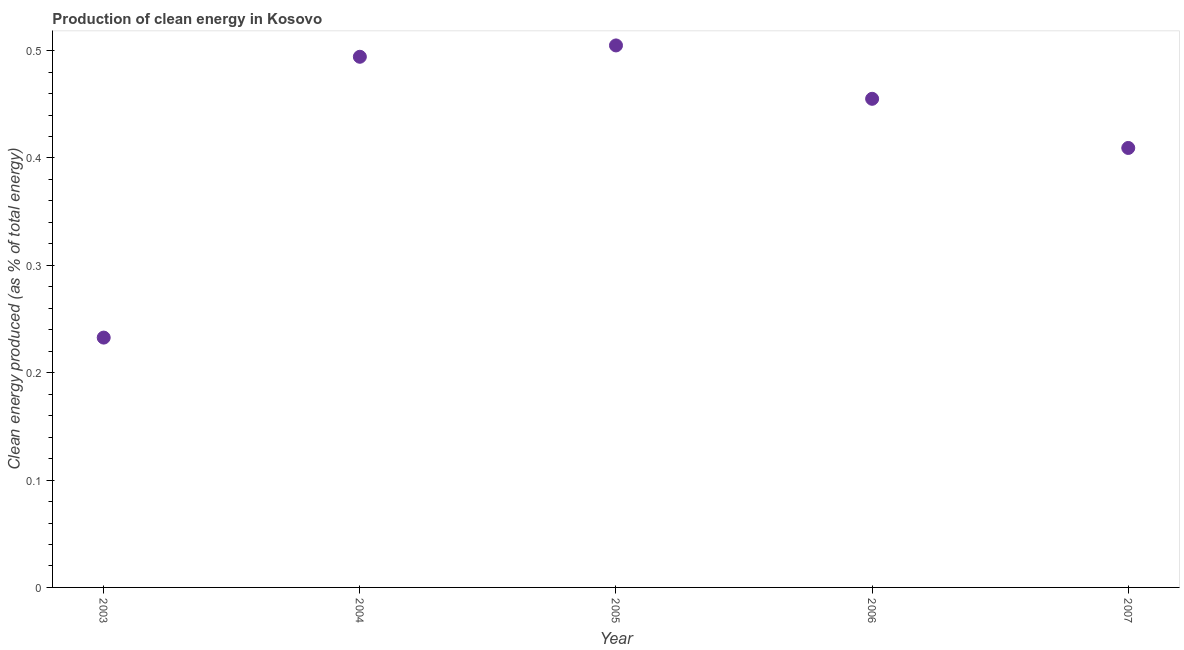What is the production of clean energy in 2006?
Provide a succinct answer. 0.46. Across all years, what is the maximum production of clean energy?
Provide a succinct answer. 0.5. Across all years, what is the minimum production of clean energy?
Your response must be concise. 0.23. In which year was the production of clean energy minimum?
Give a very brief answer. 2003. What is the sum of the production of clean energy?
Provide a succinct answer. 2.1. What is the difference between the production of clean energy in 2003 and 2006?
Offer a terse response. -0.22. What is the average production of clean energy per year?
Ensure brevity in your answer.  0.42. What is the median production of clean energy?
Offer a terse response. 0.46. What is the ratio of the production of clean energy in 2005 to that in 2006?
Your answer should be very brief. 1.11. Is the production of clean energy in 2003 less than that in 2006?
Your response must be concise. Yes. Is the difference between the production of clean energy in 2005 and 2007 greater than the difference between any two years?
Give a very brief answer. No. What is the difference between the highest and the second highest production of clean energy?
Provide a succinct answer. 0.01. What is the difference between the highest and the lowest production of clean energy?
Give a very brief answer. 0.27. In how many years, is the production of clean energy greater than the average production of clean energy taken over all years?
Provide a succinct answer. 3. Does the production of clean energy monotonically increase over the years?
Your answer should be compact. No. How many dotlines are there?
Ensure brevity in your answer.  1. Are the values on the major ticks of Y-axis written in scientific E-notation?
Your response must be concise. No. What is the title of the graph?
Offer a terse response. Production of clean energy in Kosovo. What is the label or title of the Y-axis?
Give a very brief answer. Clean energy produced (as % of total energy). What is the Clean energy produced (as % of total energy) in 2003?
Make the answer very short. 0.23. What is the Clean energy produced (as % of total energy) in 2004?
Your answer should be very brief. 0.49. What is the Clean energy produced (as % of total energy) in 2005?
Your answer should be very brief. 0.5. What is the Clean energy produced (as % of total energy) in 2006?
Offer a terse response. 0.46. What is the Clean energy produced (as % of total energy) in 2007?
Offer a very short reply. 0.41. What is the difference between the Clean energy produced (as % of total energy) in 2003 and 2004?
Offer a terse response. -0.26. What is the difference between the Clean energy produced (as % of total energy) in 2003 and 2005?
Your response must be concise. -0.27. What is the difference between the Clean energy produced (as % of total energy) in 2003 and 2006?
Provide a short and direct response. -0.22. What is the difference between the Clean energy produced (as % of total energy) in 2003 and 2007?
Keep it short and to the point. -0.18. What is the difference between the Clean energy produced (as % of total energy) in 2004 and 2005?
Provide a short and direct response. -0.01. What is the difference between the Clean energy produced (as % of total energy) in 2004 and 2006?
Provide a succinct answer. 0.04. What is the difference between the Clean energy produced (as % of total energy) in 2004 and 2007?
Your answer should be compact. 0.08. What is the difference between the Clean energy produced (as % of total energy) in 2005 and 2006?
Ensure brevity in your answer.  0.05. What is the difference between the Clean energy produced (as % of total energy) in 2005 and 2007?
Your response must be concise. 0.1. What is the difference between the Clean energy produced (as % of total energy) in 2006 and 2007?
Offer a very short reply. 0.05. What is the ratio of the Clean energy produced (as % of total energy) in 2003 to that in 2004?
Your answer should be very brief. 0.47. What is the ratio of the Clean energy produced (as % of total energy) in 2003 to that in 2005?
Make the answer very short. 0.46. What is the ratio of the Clean energy produced (as % of total energy) in 2003 to that in 2006?
Offer a terse response. 0.51. What is the ratio of the Clean energy produced (as % of total energy) in 2003 to that in 2007?
Keep it short and to the point. 0.57. What is the ratio of the Clean energy produced (as % of total energy) in 2004 to that in 2006?
Give a very brief answer. 1.09. What is the ratio of the Clean energy produced (as % of total energy) in 2004 to that in 2007?
Offer a very short reply. 1.21. What is the ratio of the Clean energy produced (as % of total energy) in 2005 to that in 2006?
Offer a very short reply. 1.11. What is the ratio of the Clean energy produced (as % of total energy) in 2005 to that in 2007?
Offer a very short reply. 1.23. What is the ratio of the Clean energy produced (as % of total energy) in 2006 to that in 2007?
Provide a succinct answer. 1.11. 